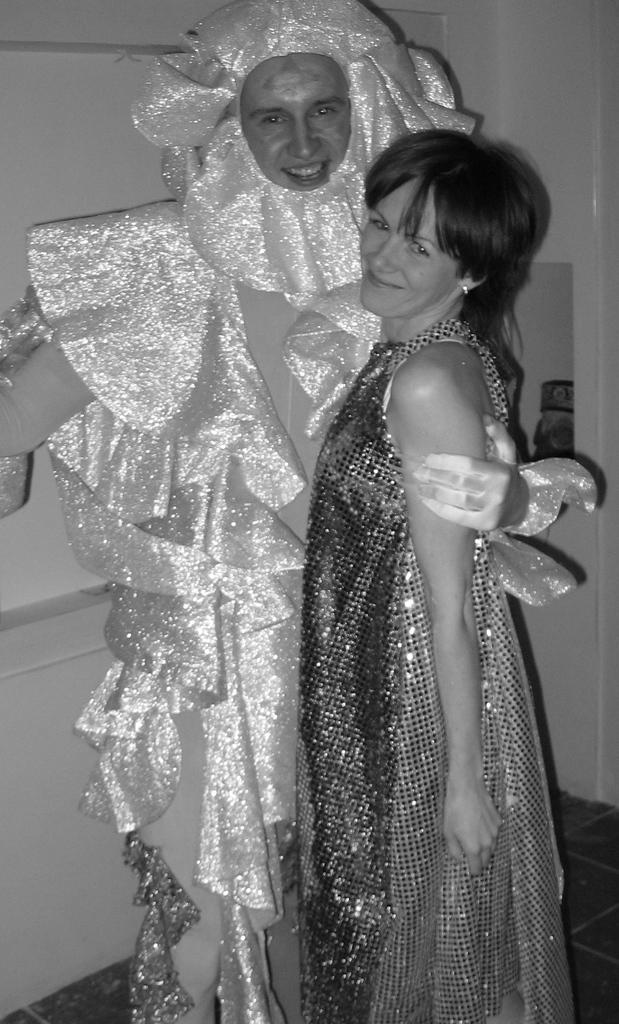Please provide a concise description of this image. This is black and white image where we can see man and woman. They are wearing costumes. Behind the wall is there. 